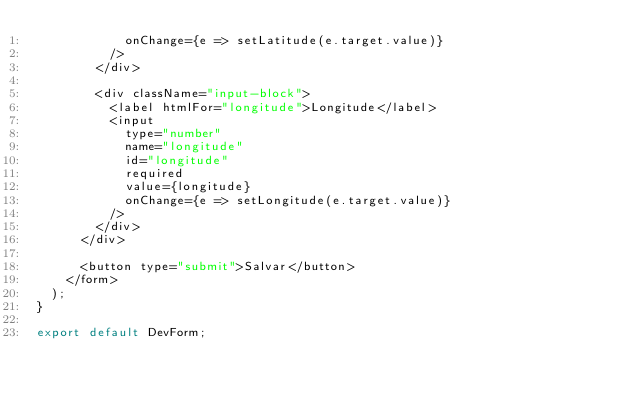Convert code to text. <code><loc_0><loc_0><loc_500><loc_500><_JavaScript_>            onChange={e => setLatitude(e.target.value)}
          />
        </div>

        <div className="input-block">
          <label htmlFor="longitude">Longitude</label>
          <input 
            type="number" 
            name="longitude" 
            id="longitude" 
            required 
            value={longitude} 
            onChange={e => setLongitude(e.target.value)}
          />
        </div>
      </div>

      <button type="submit">Salvar</button>
    </form>
  );
}

export default DevForm;</code> 